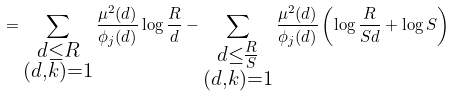<formula> <loc_0><loc_0><loc_500><loc_500>= \sum _ { \substack { d \leq R \\ ( d , k ) = 1 } } \frac { \mu ^ { 2 } ( d ) } { \phi _ { j } ( d ) } \log \frac { R } { d } - \sum _ { \substack { d \leq \frac { R } { S } \\ ( d , k ) = 1 } } \frac { \mu ^ { 2 } ( d ) } { \phi _ { j } ( d ) } \left ( \log \frac { R } { S d } + \log S \right )</formula> 